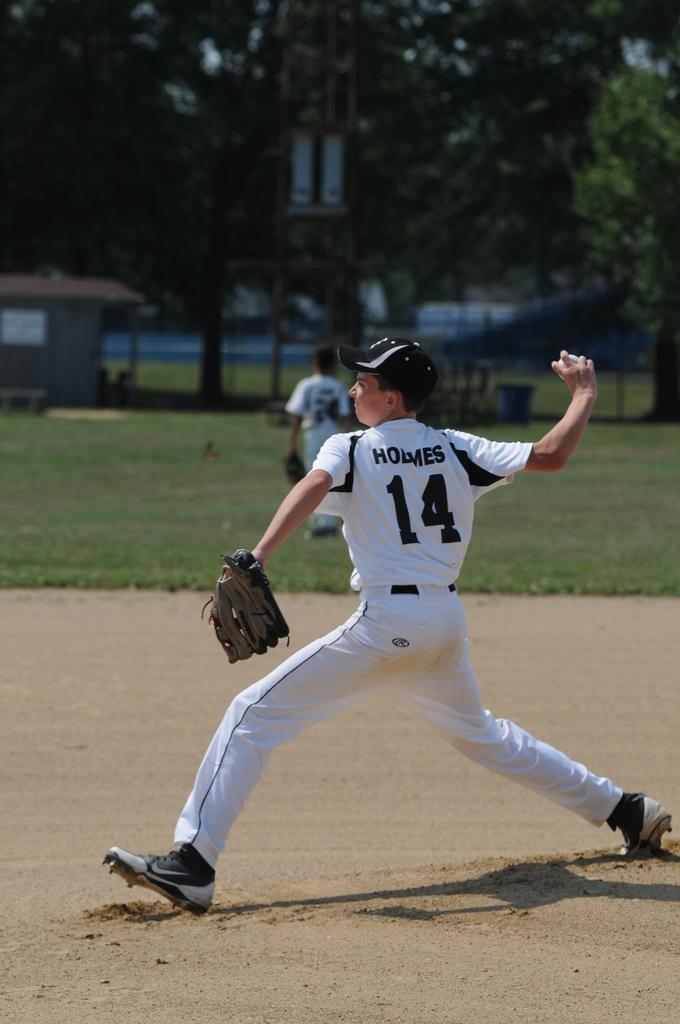<image>
Describe the image concisely. kids plying baseball player is homes number 14 